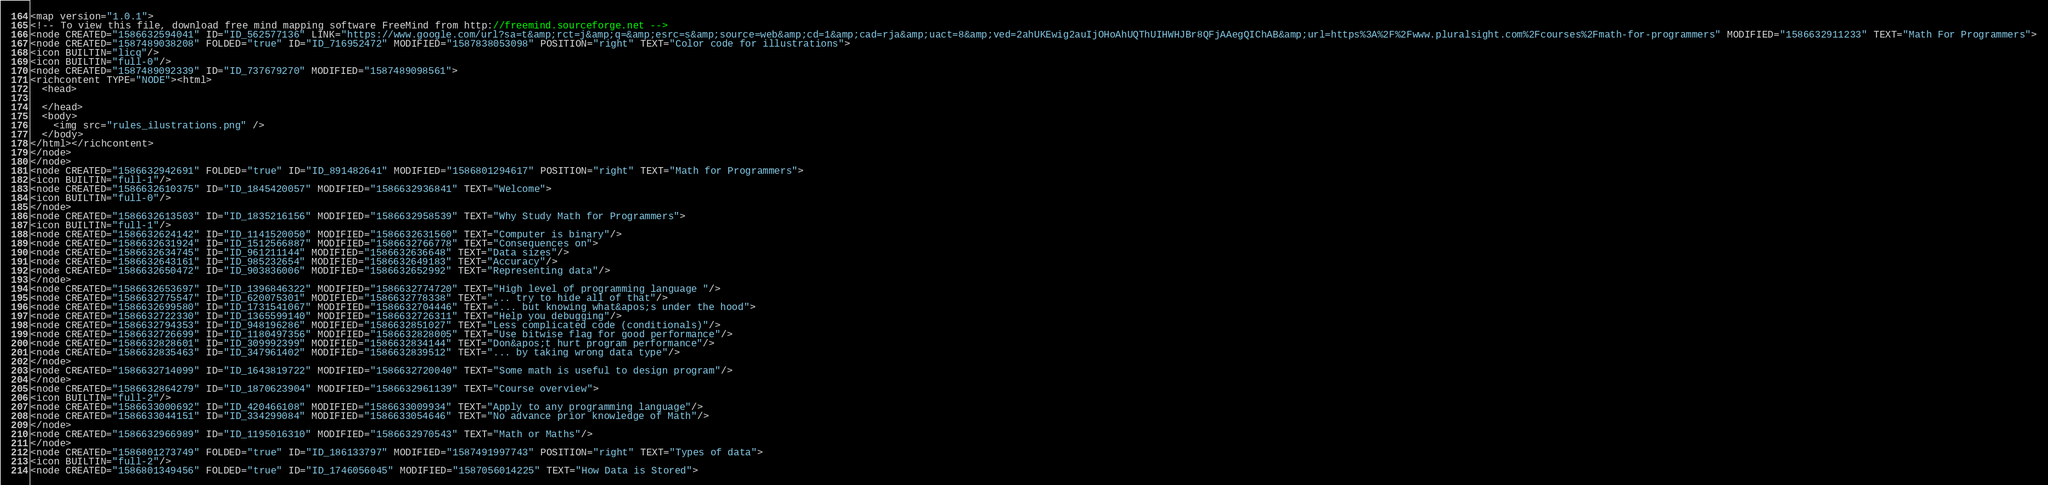<code> <loc_0><loc_0><loc_500><loc_500><_ObjectiveC_><map version="1.0.1">
<!-- To view this file, download free mind mapping software FreeMind from http://freemind.sourceforge.net -->
<node CREATED="1586632594041" ID="ID_562577136" LINK="https://www.google.com/url?sa=t&amp;rct=j&amp;q=&amp;esrc=s&amp;source=web&amp;cd=1&amp;cad=rja&amp;uact=8&amp;ved=2ahUKEwig2auIjOHoAhUQThUIHWHJBr8QFjAAegQIChAB&amp;url=https%3A%2F%2Fwww.pluralsight.com%2Fcourses%2Fmath-for-programmers" MODIFIED="1586632911233" TEXT="Math For Programmers">
<node CREATED="1587489038208" FOLDED="true" ID="ID_716952472" MODIFIED="1587838053098" POSITION="right" TEXT="Color code for illustrations">
<icon BUILTIN="licq"/>
<icon BUILTIN="full-0"/>
<node CREATED="1587489092339" ID="ID_737679270" MODIFIED="1587489098561">
<richcontent TYPE="NODE"><html>
  <head>
    
  </head>
  <body>
    <img src="rules_ilustrations.png" />
  </body>
</html></richcontent>
</node>
</node>
<node CREATED="1586632942691" FOLDED="true" ID="ID_891482641" MODIFIED="1586801294617" POSITION="right" TEXT="Math for Programmers">
<icon BUILTIN="full-1"/>
<node CREATED="1586632610375" ID="ID_1845420057" MODIFIED="1586632936841" TEXT="Welcome">
<icon BUILTIN="full-0"/>
</node>
<node CREATED="1586632613503" ID="ID_1835216156" MODIFIED="1586632958539" TEXT="Why Study Math for Programmers">
<icon BUILTIN="full-1"/>
<node CREATED="1586632624142" ID="ID_1141520050" MODIFIED="1586632631560" TEXT="Computer is binary"/>
<node CREATED="1586632631924" ID="ID_1512566887" MODIFIED="1586632766778" TEXT="Consequences on">
<node CREATED="1586632634745" ID="ID_961211144" MODIFIED="1586632636648" TEXT="Data sizes"/>
<node CREATED="1586632643161" ID="ID_985232654" MODIFIED="1586632649183" TEXT="Accuracy"/>
<node CREATED="1586632650472" ID="ID_903836006" MODIFIED="1586632652992" TEXT="Representing data"/>
</node>
<node CREATED="1586632653697" ID="ID_1396846322" MODIFIED="1586632774720" TEXT="High level of programming language "/>
<node CREATED="1586632775547" ID="ID_620075301" MODIFIED="1586632778338" TEXT="... try to hide all of that"/>
<node CREATED="1586632699580" ID="ID_1731541067" MODIFIED="1586632704446" TEXT="... but knowing what&apos;s under the hood">
<node CREATED="1586632722330" ID="ID_1365599140" MODIFIED="1586632726311" TEXT="Help you debugging"/>
<node CREATED="1586632794353" ID="ID_948196286" MODIFIED="1586632851027" TEXT="Less complicated code (conditionals)"/>
<node CREATED="1586632726699" ID="ID_1180497356" MODIFIED="1586632828005" TEXT="Use bitwise flag for good performance"/>
<node CREATED="1586632828601" ID="ID_309992399" MODIFIED="1586632834144" TEXT="Don&apos;t hurt program performance"/>
<node CREATED="1586632835463" ID="ID_347961402" MODIFIED="1586632839512" TEXT="... by taking wrong data type"/>
</node>
<node CREATED="1586632714099" ID="ID_1643819722" MODIFIED="1586632720040" TEXT="Some math is useful to design program"/>
</node>
<node CREATED="1586632864279" ID="ID_1870623904" MODIFIED="1586632961139" TEXT="Course overview">
<icon BUILTIN="full-2"/>
<node CREATED="1586633000692" ID="ID_420466108" MODIFIED="1586633009934" TEXT="Apply to any programming language"/>
<node CREATED="1586633044151" ID="ID_334299084" MODIFIED="1586633054646" TEXT="No advance prior knowledge of Math"/>
</node>
<node CREATED="1586632966989" ID="ID_1195016310" MODIFIED="1586632970543" TEXT="Math or Maths"/>
</node>
<node CREATED="1586801273749" FOLDED="true" ID="ID_186133797" MODIFIED="1587491997743" POSITION="right" TEXT="Types of data">
<icon BUILTIN="full-2"/>
<node CREATED="1586801349456" FOLDED="true" ID="ID_1746056045" MODIFIED="1587056014225" TEXT="How Data is Stored"></code> 